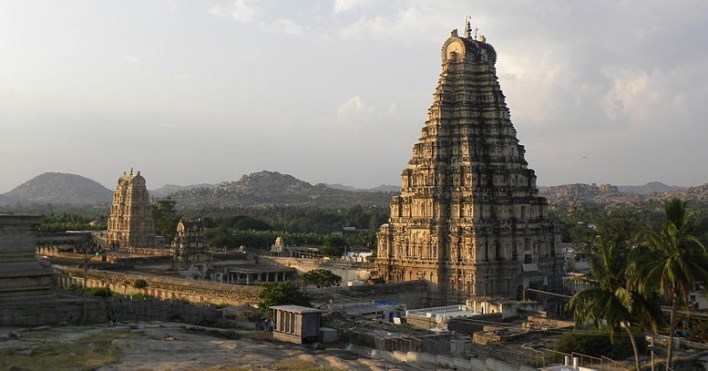Explain the visual content of the image in great detail. The image showcases the majestic Virupaksha Temple, an ancient relic and a pivotal element of the Hampi UNESCO World Heritage Site in India. This temple is consecrated to Lord Shiva and is renowned for its towering gopuram, an architectural term for the monumental tower, which is elaborately embellished with divine mythological carvings that depict tales from Hindu scriptures.

Situated amidst a landscape rich with palm trees and granite boulders, the temple's surroundings are peppered with the remnants of historical outbuildings that speak volumes about Hampi's storied past. A clear blue sky provides a serene backdrop to this striking complex. The image, potentially captured during the golden hour based on the ambient lighting, paints the scene with a soft, diffuse light, subsequently highlighting the temple's intricate details and the undulating terrain. 